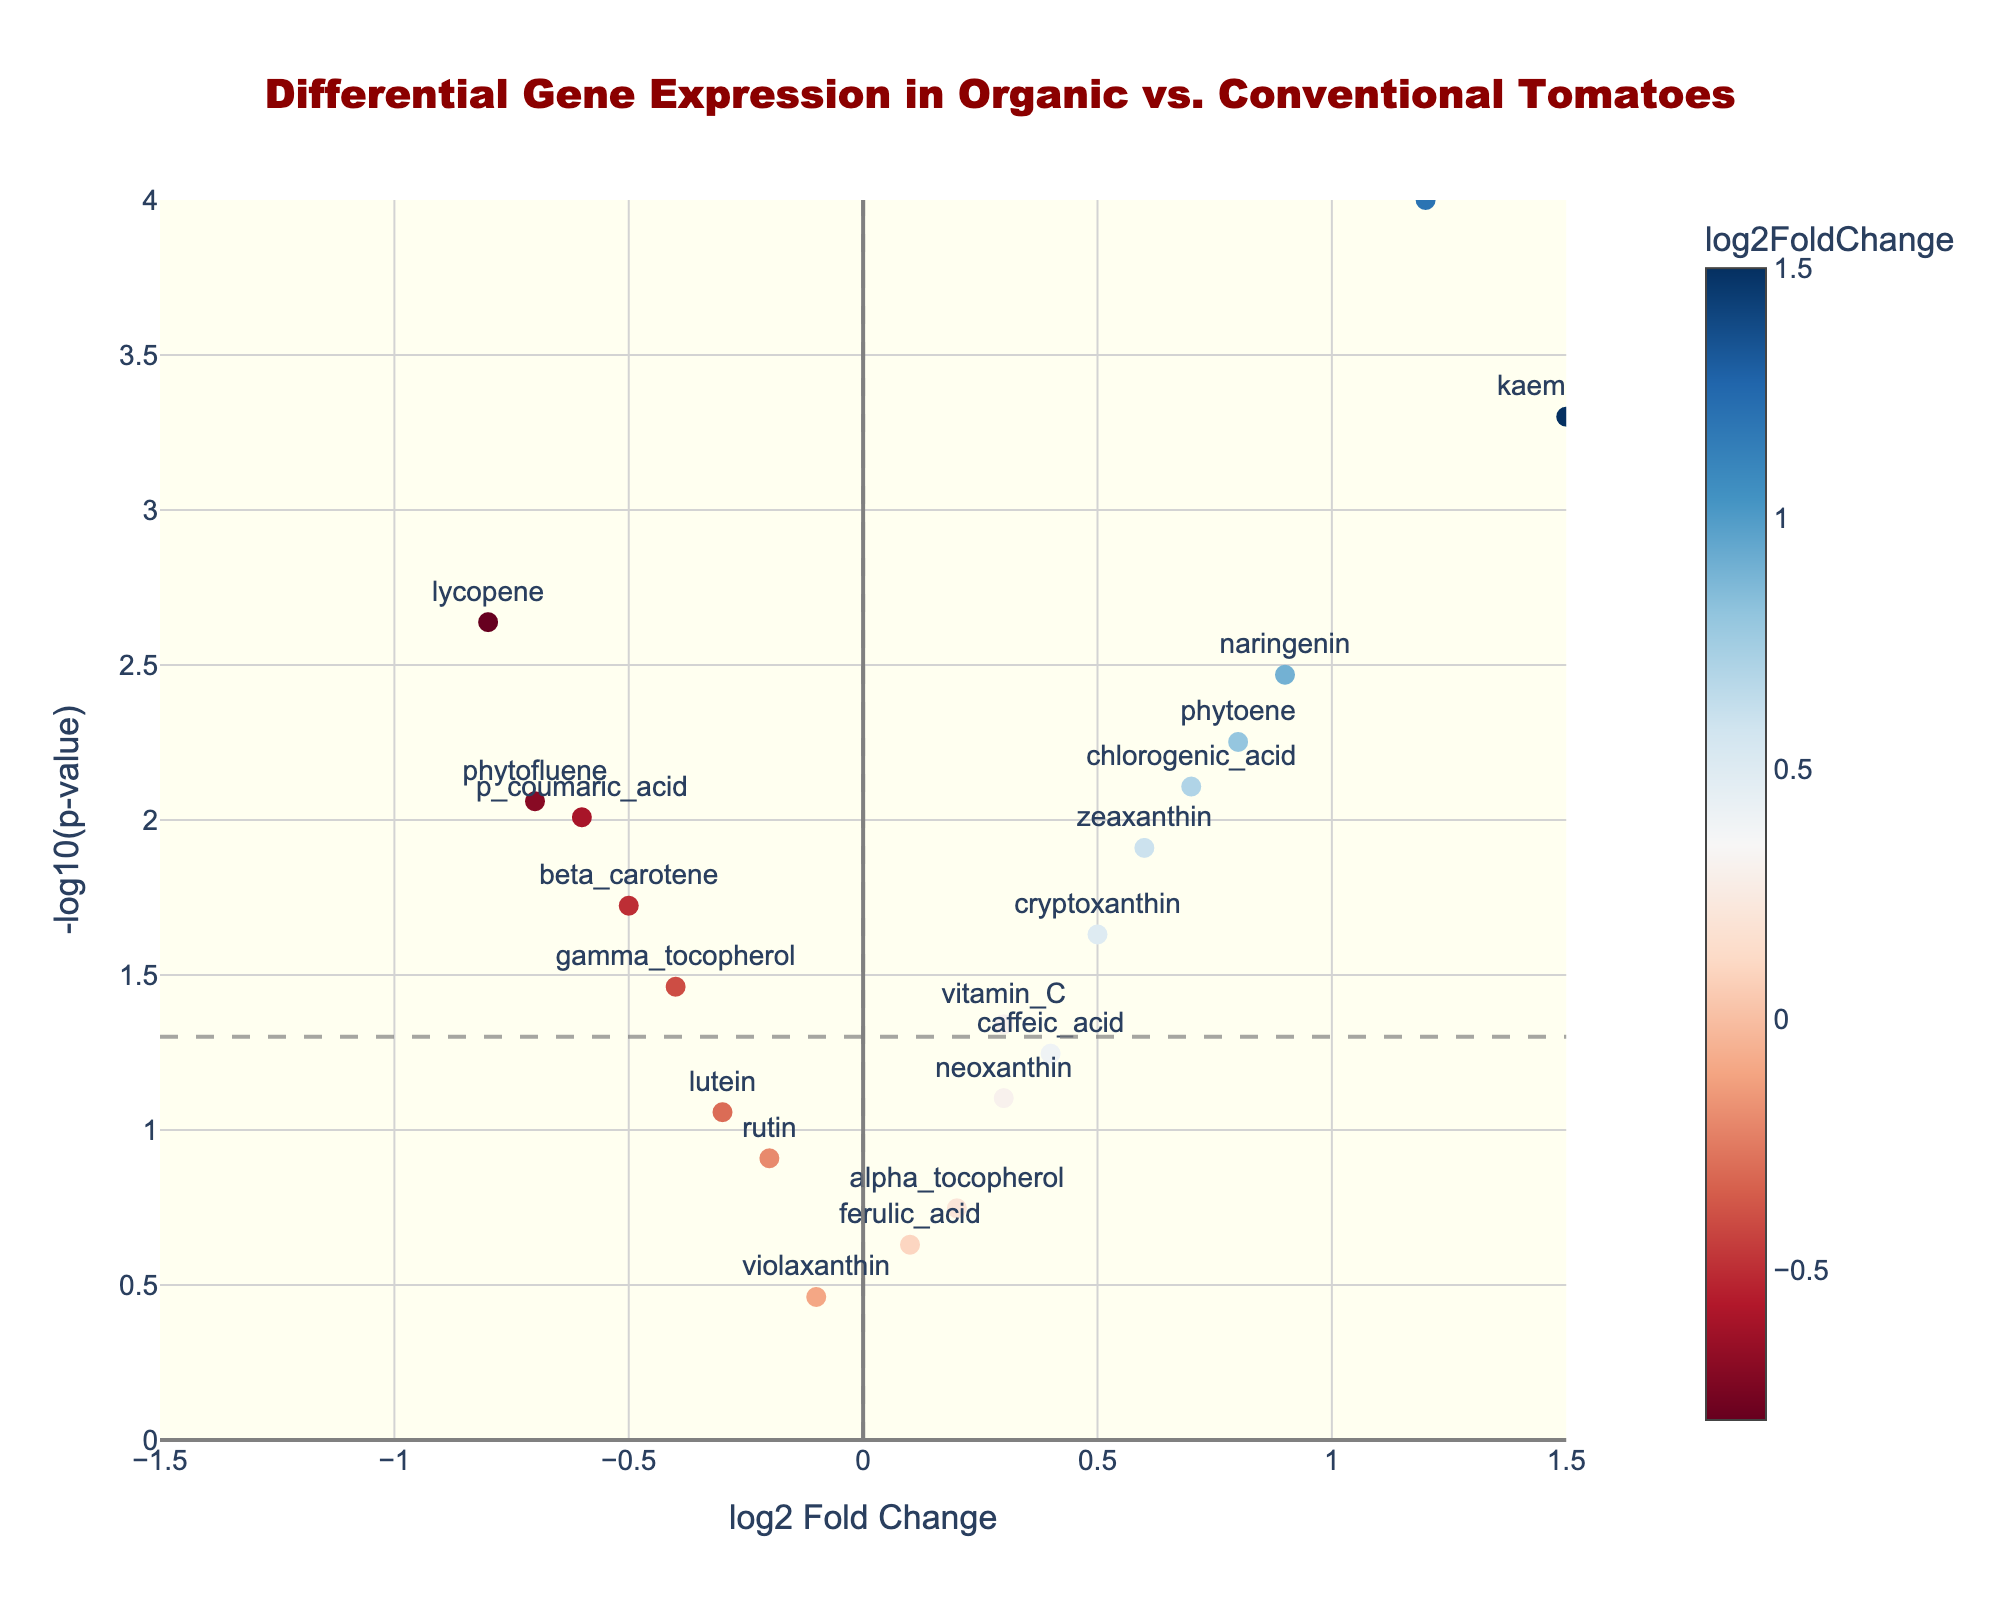What is the title of the figure? The title is usually displayed at the top center of the figure. Here it says "Differential Gene Expression in Organic vs. Conventional Tomatoes".
Answer: Differential Gene Expression in Organic vs. Conventional Tomatoes How many genes are shown with a positive log2 Fold Change? By looking at the x-axis, which represents the log2 Fold Change, locate genes that are positioned to the right of the vertical line at x=0. Count these genes.
Answer: 10 Which gene has the highest -log10(p-value)? -log10(p-value) is represented on the y-axis. The gene with the highest value on this axis will have the highest -log10(p-value). In the plot, it's the gene at the top-most point (quercetin).
Answer: quercetin What is the log2 Fold Change value of 'lycopene'? Locate the position of 'lycopene' on the x-axis, and refer to its value on this axis, which is labeled directly on the plot.
Answer: -0.8 Which genes have a -log10(p-value) above the threshold line associated with p=0.05? The threshold line for p=0.05 is at -log10(0.05) ≈ 1.3. Identify all the genes with y-values (on the -log10(p-value) axis) above this line. These are quercetin, kaempferol, naringenin, phytoene, chlorogenic_acid, zeaxanthin, p_coumaric_acid, phytofluene, and lycopene.
Answer: quercetin, kaempferol, naringenin, phytoene, chlorogenic_acid, zeaxanthin, p_coumaric_acid, phytofluene, lycopene What is the log2FoldChange range shown in the figure? The x-axis represents the log2FoldChange values. Identify the minimum and maximum values represented on this axis.
Answer: -1.5 to 1.5 Which gene shows the highest positive log2 Fold Change? Refer to the x-axis, where the gene with the highest positive value on this axis has the highest positive log2 Fold Change. The gene positioned furthest to the right is 'kaempferol'.
Answer: kaempferol Which gene has the highest negative log2 Fold Change and is also statistically significant with p < 0.05? Among genes with negative log2 Fold Change, find the one with the farthest position to the left and an accompanying p-value less than 0.05. This gene is 'lycopene'.
Answer: lycopene 